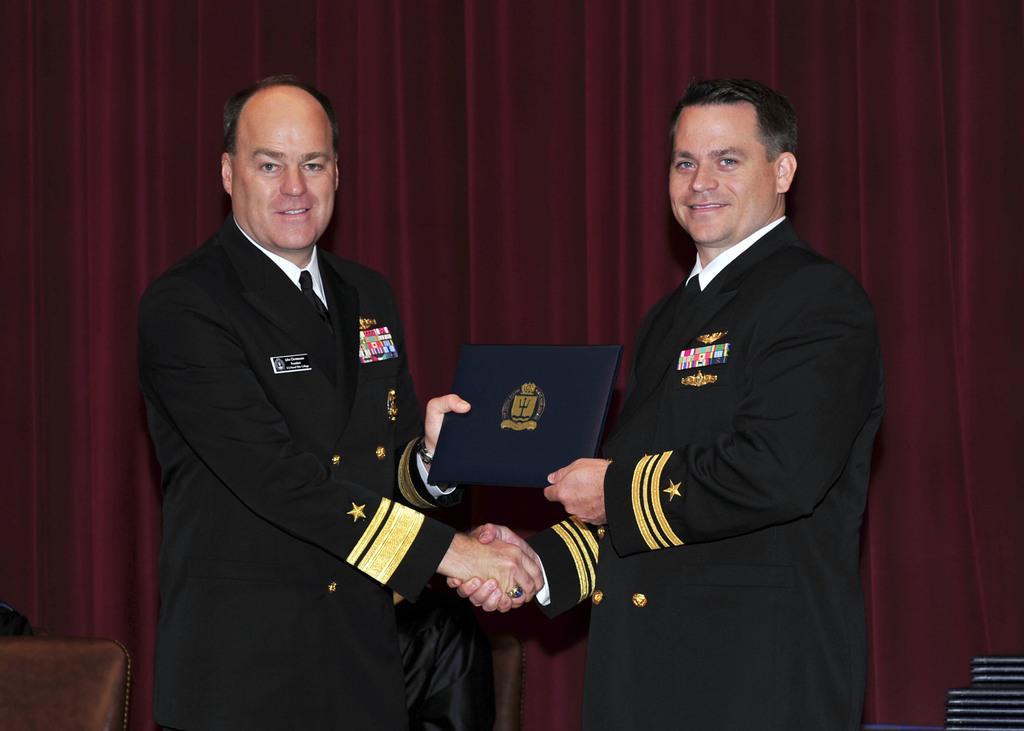Please provide a concise description of this image. In the picture we can see two men are standing in the uniforms, holding each other hand and in the background we can see the curtain. 